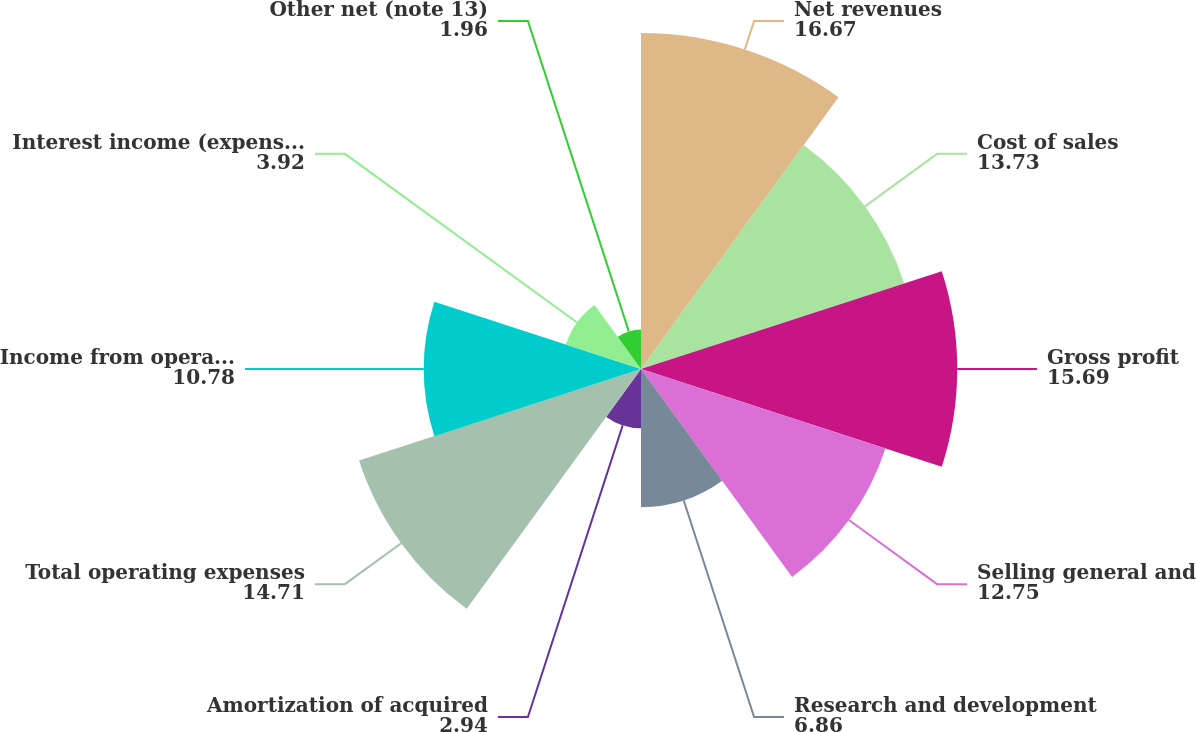Convert chart to OTSL. <chart><loc_0><loc_0><loc_500><loc_500><pie_chart><fcel>Net revenues<fcel>Cost of sales<fcel>Gross profit<fcel>Selling general and<fcel>Research and development<fcel>Amortization of acquired<fcel>Total operating expenses<fcel>Income from operations<fcel>Interest income (expense) net<fcel>Other net (note 13)<nl><fcel>16.67%<fcel>13.73%<fcel>15.69%<fcel>12.75%<fcel>6.86%<fcel>2.94%<fcel>14.71%<fcel>10.78%<fcel>3.92%<fcel>1.96%<nl></chart> 